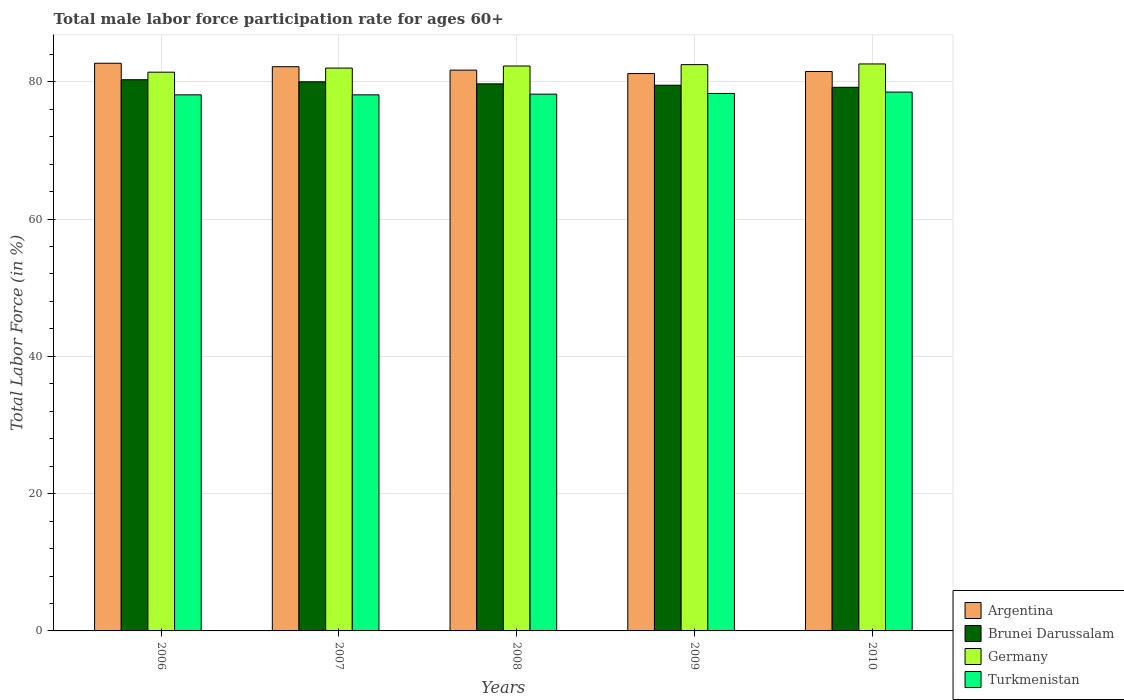How many groups of bars are there?
Give a very brief answer. 5. Are the number of bars per tick equal to the number of legend labels?
Keep it short and to the point. Yes. Are the number of bars on each tick of the X-axis equal?
Your response must be concise. Yes. How many bars are there on the 4th tick from the left?
Your response must be concise. 4. In how many cases, is the number of bars for a given year not equal to the number of legend labels?
Your answer should be compact. 0. What is the male labor force participation rate in Germany in 2007?
Your answer should be very brief. 82. Across all years, what is the maximum male labor force participation rate in Argentina?
Make the answer very short. 82.7. Across all years, what is the minimum male labor force participation rate in Argentina?
Provide a short and direct response. 81.2. What is the total male labor force participation rate in Argentina in the graph?
Your response must be concise. 409.3. What is the difference between the male labor force participation rate in Brunei Darussalam in 2007 and that in 2010?
Give a very brief answer. 0.8. What is the difference between the male labor force participation rate in Argentina in 2008 and the male labor force participation rate in Germany in 2009?
Your answer should be very brief. -0.8. What is the average male labor force participation rate in Brunei Darussalam per year?
Give a very brief answer. 79.74. In the year 2006, what is the difference between the male labor force participation rate in Germany and male labor force participation rate in Argentina?
Ensure brevity in your answer.  -1.3. What is the ratio of the male labor force participation rate in Germany in 2009 to that in 2010?
Provide a succinct answer. 1. Is the difference between the male labor force participation rate in Germany in 2007 and 2010 greater than the difference between the male labor force participation rate in Argentina in 2007 and 2010?
Keep it short and to the point. No. What is the difference between the highest and the second highest male labor force participation rate in Turkmenistan?
Keep it short and to the point. 0.2. What is the difference between the highest and the lowest male labor force participation rate in Turkmenistan?
Keep it short and to the point. 0.4. In how many years, is the male labor force participation rate in Turkmenistan greater than the average male labor force participation rate in Turkmenistan taken over all years?
Your answer should be very brief. 2. Is the sum of the male labor force participation rate in Germany in 2008 and 2010 greater than the maximum male labor force participation rate in Brunei Darussalam across all years?
Ensure brevity in your answer.  Yes. What does the 2nd bar from the left in 2008 represents?
Give a very brief answer. Brunei Darussalam. What does the 1st bar from the right in 2007 represents?
Provide a short and direct response. Turkmenistan. Are all the bars in the graph horizontal?
Your answer should be compact. No. What is the difference between two consecutive major ticks on the Y-axis?
Provide a short and direct response. 20. Does the graph contain any zero values?
Offer a terse response. No. Does the graph contain grids?
Provide a succinct answer. Yes. Where does the legend appear in the graph?
Ensure brevity in your answer.  Bottom right. How many legend labels are there?
Provide a succinct answer. 4. What is the title of the graph?
Your answer should be very brief. Total male labor force participation rate for ages 60+. Does "Yemen, Rep." appear as one of the legend labels in the graph?
Provide a short and direct response. No. What is the label or title of the Y-axis?
Make the answer very short. Total Labor Force (in %). What is the Total Labor Force (in %) of Argentina in 2006?
Your answer should be compact. 82.7. What is the Total Labor Force (in %) of Brunei Darussalam in 2006?
Offer a terse response. 80.3. What is the Total Labor Force (in %) in Germany in 2006?
Keep it short and to the point. 81.4. What is the Total Labor Force (in %) in Turkmenistan in 2006?
Ensure brevity in your answer.  78.1. What is the Total Labor Force (in %) in Argentina in 2007?
Provide a short and direct response. 82.2. What is the Total Labor Force (in %) in Brunei Darussalam in 2007?
Provide a short and direct response. 80. What is the Total Labor Force (in %) in Turkmenistan in 2007?
Make the answer very short. 78.1. What is the Total Labor Force (in %) of Argentina in 2008?
Give a very brief answer. 81.7. What is the Total Labor Force (in %) in Brunei Darussalam in 2008?
Your answer should be very brief. 79.7. What is the Total Labor Force (in %) of Germany in 2008?
Provide a succinct answer. 82.3. What is the Total Labor Force (in %) in Turkmenistan in 2008?
Give a very brief answer. 78.2. What is the Total Labor Force (in %) in Argentina in 2009?
Give a very brief answer. 81.2. What is the Total Labor Force (in %) in Brunei Darussalam in 2009?
Offer a very short reply. 79.5. What is the Total Labor Force (in %) in Germany in 2009?
Offer a terse response. 82.5. What is the Total Labor Force (in %) of Turkmenistan in 2009?
Your response must be concise. 78.3. What is the Total Labor Force (in %) of Argentina in 2010?
Give a very brief answer. 81.5. What is the Total Labor Force (in %) in Brunei Darussalam in 2010?
Give a very brief answer. 79.2. What is the Total Labor Force (in %) in Germany in 2010?
Your answer should be compact. 82.6. What is the Total Labor Force (in %) of Turkmenistan in 2010?
Provide a succinct answer. 78.5. Across all years, what is the maximum Total Labor Force (in %) of Argentina?
Give a very brief answer. 82.7. Across all years, what is the maximum Total Labor Force (in %) in Brunei Darussalam?
Your answer should be compact. 80.3. Across all years, what is the maximum Total Labor Force (in %) of Germany?
Provide a short and direct response. 82.6. Across all years, what is the maximum Total Labor Force (in %) in Turkmenistan?
Give a very brief answer. 78.5. Across all years, what is the minimum Total Labor Force (in %) in Argentina?
Make the answer very short. 81.2. Across all years, what is the minimum Total Labor Force (in %) of Brunei Darussalam?
Provide a succinct answer. 79.2. Across all years, what is the minimum Total Labor Force (in %) of Germany?
Ensure brevity in your answer.  81.4. Across all years, what is the minimum Total Labor Force (in %) of Turkmenistan?
Your response must be concise. 78.1. What is the total Total Labor Force (in %) of Argentina in the graph?
Offer a terse response. 409.3. What is the total Total Labor Force (in %) of Brunei Darussalam in the graph?
Ensure brevity in your answer.  398.7. What is the total Total Labor Force (in %) in Germany in the graph?
Your answer should be very brief. 410.8. What is the total Total Labor Force (in %) of Turkmenistan in the graph?
Your answer should be compact. 391.2. What is the difference between the Total Labor Force (in %) of Brunei Darussalam in 2006 and that in 2007?
Your response must be concise. 0.3. What is the difference between the Total Labor Force (in %) in Germany in 2006 and that in 2007?
Provide a short and direct response. -0.6. What is the difference between the Total Labor Force (in %) in Brunei Darussalam in 2006 and that in 2008?
Your answer should be very brief. 0.6. What is the difference between the Total Labor Force (in %) of Germany in 2006 and that in 2008?
Your answer should be very brief. -0.9. What is the difference between the Total Labor Force (in %) of Turkmenistan in 2006 and that in 2010?
Provide a succinct answer. -0.4. What is the difference between the Total Labor Force (in %) in Argentina in 2007 and that in 2008?
Offer a very short reply. 0.5. What is the difference between the Total Labor Force (in %) in Germany in 2007 and that in 2008?
Keep it short and to the point. -0.3. What is the difference between the Total Labor Force (in %) in Turkmenistan in 2007 and that in 2008?
Keep it short and to the point. -0.1. What is the difference between the Total Labor Force (in %) of Brunei Darussalam in 2007 and that in 2009?
Keep it short and to the point. 0.5. What is the difference between the Total Labor Force (in %) of Turkmenistan in 2007 and that in 2010?
Ensure brevity in your answer.  -0.4. What is the difference between the Total Labor Force (in %) in Argentina in 2008 and that in 2009?
Your answer should be compact. 0.5. What is the difference between the Total Labor Force (in %) of Germany in 2008 and that in 2009?
Ensure brevity in your answer.  -0.2. What is the difference between the Total Labor Force (in %) in Turkmenistan in 2008 and that in 2009?
Your answer should be very brief. -0.1. What is the difference between the Total Labor Force (in %) of Germany in 2008 and that in 2010?
Make the answer very short. -0.3. What is the difference between the Total Labor Force (in %) of Argentina in 2009 and that in 2010?
Your response must be concise. -0.3. What is the difference between the Total Labor Force (in %) of Turkmenistan in 2009 and that in 2010?
Your answer should be compact. -0.2. What is the difference between the Total Labor Force (in %) in Argentina in 2006 and the Total Labor Force (in %) in Brunei Darussalam in 2007?
Keep it short and to the point. 2.7. What is the difference between the Total Labor Force (in %) in Argentina in 2006 and the Total Labor Force (in %) in Turkmenistan in 2007?
Keep it short and to the point. 4.6. What is the difference between the Total Labor Force (in %) in Brunei Darussalam in 2006 and the Total Labor Force (in %) in Germany in 2007?
Offer a terse response. -1.7. What is the difference between the Total Labor Force (in %) of Brunei Darussalam in 2006 and the Total Labor Force (in %) of Turkmenistan in 2007?
Offer a very short reply. 2.2. What is the difference between the Total Labor Force (in %) of Argentina in 2006 and the Total Labor Force (in %) of Turkmenistan in 2008?
Offer a very short reply. 4.5. What is the difference between the Total Labor Force (in %) in Brunei Darussalam in 2006 and the Total Labor Force (in %) in Turkmenistan in 2008?
Make the answer very short. 2.1. What is the difference between the Total Labor Force (in %) in Germany in 2006 and the Total Labor Force (in %) in Turkmenistan in 2008?
Your answer should be compact. 3.2. What is the difference between the Total Labor Force (in %) of Argentina in 2006 and the Total Labor Force (in %) of Brunei Darussalam in 2009?
Provide a succinct answer. 3.2. What is the difference between the Total Labor Force (in %) in Argentina in 2006 and the Total Labor Force (in %) in Germany in 2009?
Your response must be concise. 0.2. What is the difference between the Total Labor Force (in %) of Brunei Darussalam in 2006 and the Total Labor Force (in %) of Turkmenistan in 2009?
Make the answer very short. 2. What is the difference between the Total Labor Force (in %) in Germany in 2006 and the Total Labor Force (in %) in Turkmenistan in 2009?
Ensure brevity in your answer.  3.1. What is the difference between the Total Labor Force (in %) of Germany in 2006 and the Total Labor Force (in %) of Turkmenistan in 2010?
Provide a short and direct response. 2.9. What is the difference between the Total Labor Force (in %) of Argentina in 2007 and the Total Labor Force (in %) of Brunei Darussalam in 2008?
Offer a very short reply. 2.5. What is the difference between the Total Labor Force (in %) in Argentina in 2007 and the Total Labor Force (in %) in Germany in 2008?
Provide a succinct answer. -0.1. What is the difference between the Total Labor Force (in %) in Germany in 2007 and the Total Labor Force (in %) in Turkmenistan in 2008?
Provide a short and direct response. 3.8. What is the difference between the Total Labor Force (in %) of Argentina in 2007 and the Total Labor Force (in %) of Brunei Darussalam in 2009?
Your answer should be compact. 2.7. What is the difference between the Total Labor Force (in %) in Brunei Darussalam in 2007 and the Total Labor Force (in %) in Germany in 2009?
Your answer should be very brief. -2.5. What is the difference between the Total Labor Force (in %) in Brunei Darussalam in 2007 and the Total Labor Force (in %) in Turkmenistan in 2009?
Your answer should be compact. 1.7. What is the difference between the Total Labor Force (in %) in Argentina in 2007 and the Total Labor Force (in %) in Brunei Darussalam in 2010?
Your answer should be compact. 3. What is the difference between the Total Labor Force (in %) in Brunei Darussalam in 2007 and the Total Labor Force (in %) in Germany in 2010?
Provide a succinct answer. -2.6. What is the difference between the Total Labor Force (in %) in Argentina in 2008 and the Total Labor Force (in %) in Turkmenistan in 2009?
Offer a very short reply. 3.4. What is the difference between the Total Labor Force (in %) of Brunei Darussalam in 2008 and the Total Labor Force (in %) of Turkmenistan in 2009?
Offer a very short reply. 1.4. What is the difference between the Total Labor Force (in %) of Argentina in 2008 and the Total Labor Force (in %) of Brunei Darussalam in 2010?
Ensure brevity in your answer.  2.5. What is the difference between the Total Labor Force (in %) of Germany in 2008 and the Total Labor Force (in %) of Turkmenistan in 2010?
Offer a very short reply. 3.8. What is the difference between the Total Labor Force (in %) of Argentina in 2009 and the Total Labor Force (in %) of Brunei Darussalam in 2010?
Offer a terse response. 2. What is the difference between the Total Labor Force (in %) of Argentina in 2009 and the Total Labor Force (in %) of Turkmenistan in 2010?
Provide a short and direct response. 2.7. What is the difference between the Total Labor Force (in %) in Brunei Darussalam in 2009 and the Total Labor Force (in %) in Germany in 2010?
Your response must be concise. -3.1. What is the difference between the Total Labor Force (in %) in Brunei Darussalam in 2009 and the Total Labor Force (in %) in Turkmenistan in 2010?
Provide a short and direct response. 1. What is the average Total Labor Force (in %) in Argentina per year?
Make the answer very short. 81.86. What is the average Total Labor Force (in %) in Brunei Darussalam per year?
Your answer should be compact. 79.74. What is the average Total Labor Force (in %) of Germany per year?
Provide a short and direct response. 82.16. What is the average Total Labor Force (in %) of Turkmenistan per year?
Keep it short and to the point. 78.24. In the year 2006, what is the difference between the Total Labor Force (in %) of Argentina and Total Labor Force (in %) of Brunei Darussalam?
Give a very brief answer. 2.4. In the year 2006, what is the difference between the Total Labor Force (in %) in Argentina and Total Labor Force (in %) in Germany?
Offer a terse response. 1.3. In the year 2006, what is the difference between the Total Labor Force (in %) of Argentina and Total Labor Force (in %) of Turkmenistan?
Your answer should be compact. 4.6. In the year 2007, what is the difference between the Total Labor Force (in %) of Brunei Darussalam and Total Labor Force (in %) of Germany?
Provide a succinct answer. -2. In the year 2007, what is the difference between the Total Labor Force (in %) in Brunei Darussalam and Total Labor Force (in %) in Turkmenistan?
Keep it short and to the point. 1.9. In the year 2007, what is the difference between the Total Labor Force (in %) of Germany and Total Labor Force (in %) of Turkmenistan?
Provide a short and direct response. 3.9. In the year 2008, what is the difference between the Total Labor Force (in %) of Argentina and Total Labor Force (in %) of Turkmenistan?
Keep it short and to the point. 3.5. In the year 2008, what is the difference between the Total Labor Force (in %) in Brunei Darussalam and Total Labor Force (in %) in Germany?
Offer a very short reply. -2.6. In the year 2008, what is the difference between the Total Labor Force (in %) in Brunei Darussalam and Total Labor Force (in %) in Turkmenistan?
Provide a short and direct response. 1.5. In the year 2009, what is the difference between the Total Labor Force (in %) of Brunei Darussalam and Total Labor Force (in %) of Germany?
Give a very brief answer. -3. In the year 2009, what is the difference between the Total Labor Force (in %) in Brunei Darussalam and Total Labor Force (in %) in Turkmenistan?
Provide a short and direct response. 1.2. In the year 2009, what is the difference between the Total Labor Force (in %) of Germany and Total Labor Force (in %) of Turkmenistan?
Your response must be concise. 4.2. In the year 2010, what is the difference between the Total Labor Force (in %) in Argentina and Total Labor Force (in %) in Brunei Darussalam?
Make the answer very short. 2.3. In the year 2010, what is the difference between the Total Labor Force (in %) of Brunei Darussalam and Total Labor Force (in %) of Germany?
Your response must be concise. -3.4. What is the ratio of the Total Labor Force (in %) of Argentina in 2006 to that in 2008?
Offer a terse response. 1.01. What is the ratio of the Total Labor Force (in %) of Brunei Darussalam in 2006 to that in 2008?
Make the answer very short. 1.01. What is the ratio of the Total Labor Force (in %) of Argentina in 2006 to that in 2009?
Provide a succinct answer. 1.02. What is the ratio of the Total Labor Force (in %) in Germany in 2006 to that in 2009?
Offer a terse response. 0.99. What is the ratio of the Total Labor Force (in %) of Turkmenistan in 2006 to that in 2009?
Your response must be concise. 1. What is the ratio of the Total Labor Force (in %) of Argentina in 2006 to that in 2010?
Provide a succinct answer. 1.01. What is the ratio of the Total Labor Force (in %) in Brunei Darussalam in 2006 to that in 2010?
Your answer should be compact. 1.01. What is the ratio of the Total Labor Force (in %) of Germany in 2006 to that in 2010?
Your response must be concise. 0.99. What is the ratio of the Total Labor Force (in %) of Turkmenistan in 2006 to that in 2010?
Provide a succinct answer. 0.99. What is the ratio of the Total Labor Force (in %) of Turkmenistan in 2007 to that in 2008?
Ensure brevity in your answer.  1. What is the ratio of the Total Labor Force (in %) in Argentina in 2007 to that in 2009?
Your response must be concise. 1.01. What is the ratio of the Total Labor Force (in %) of Brunei Darussalam in 2007 to that in 2009?
Give a very brief answer. 1.01. What is the ratio of the Total Labor Force (in %) in Turkmenistan in 2007 to that in 2009?
Make the answer very short. 1. What is the ratio of the Total Labor Force (in %) of Argentina in 2007 to that in 2010?
Keep it short and to the point. 1.01. What is the ratio of the Total Labor Force (in %) of Brunei Darussalam in 2007 to that in 2010?
Your answer should be compact. 1.01. What is the ratio of the Total Labor Force (in %) of Germany in 2007 to that in 2010?
Keep it short and to the point. 0.99. What is the ratio of the Total Labor Force (in %) in Turkmenistan in 2007 to that in 2010?
Provide a succinct answer. 0.99. What is the ratio of the Total Labor Force (in %) in Argentina in 2008 to that in 2009?
Provide a short and direct response. 1.01. What is the ratio of the Total Labor Force (in %) of Germany in 2008 to that in 2009?
Provide a succinct answer. 1. What is the ratio of the Total Labor Force (in %) in Turkmenistan in 2008 to that in 2010?
Your answer should be very brief. 1. What is the ratio of the Total Labor Force (in %) in Turkmenistan in 2009 to that in 2010?
Keep it short and to the point. 1. What is the difference between the highest and the second highest Total Labor Force (in %) of Argentina?
Ensure brevity in your answer.  0.5. What is the difference between the highest and the lowest Total Labor Force (in %) of Argentina?
Offer a terse response. 1.5. What is the difference between the highest and the lowest Total Labor Force (in %) of Brunei Darussalam?
Ensure brevity in your answer.  1.1. 